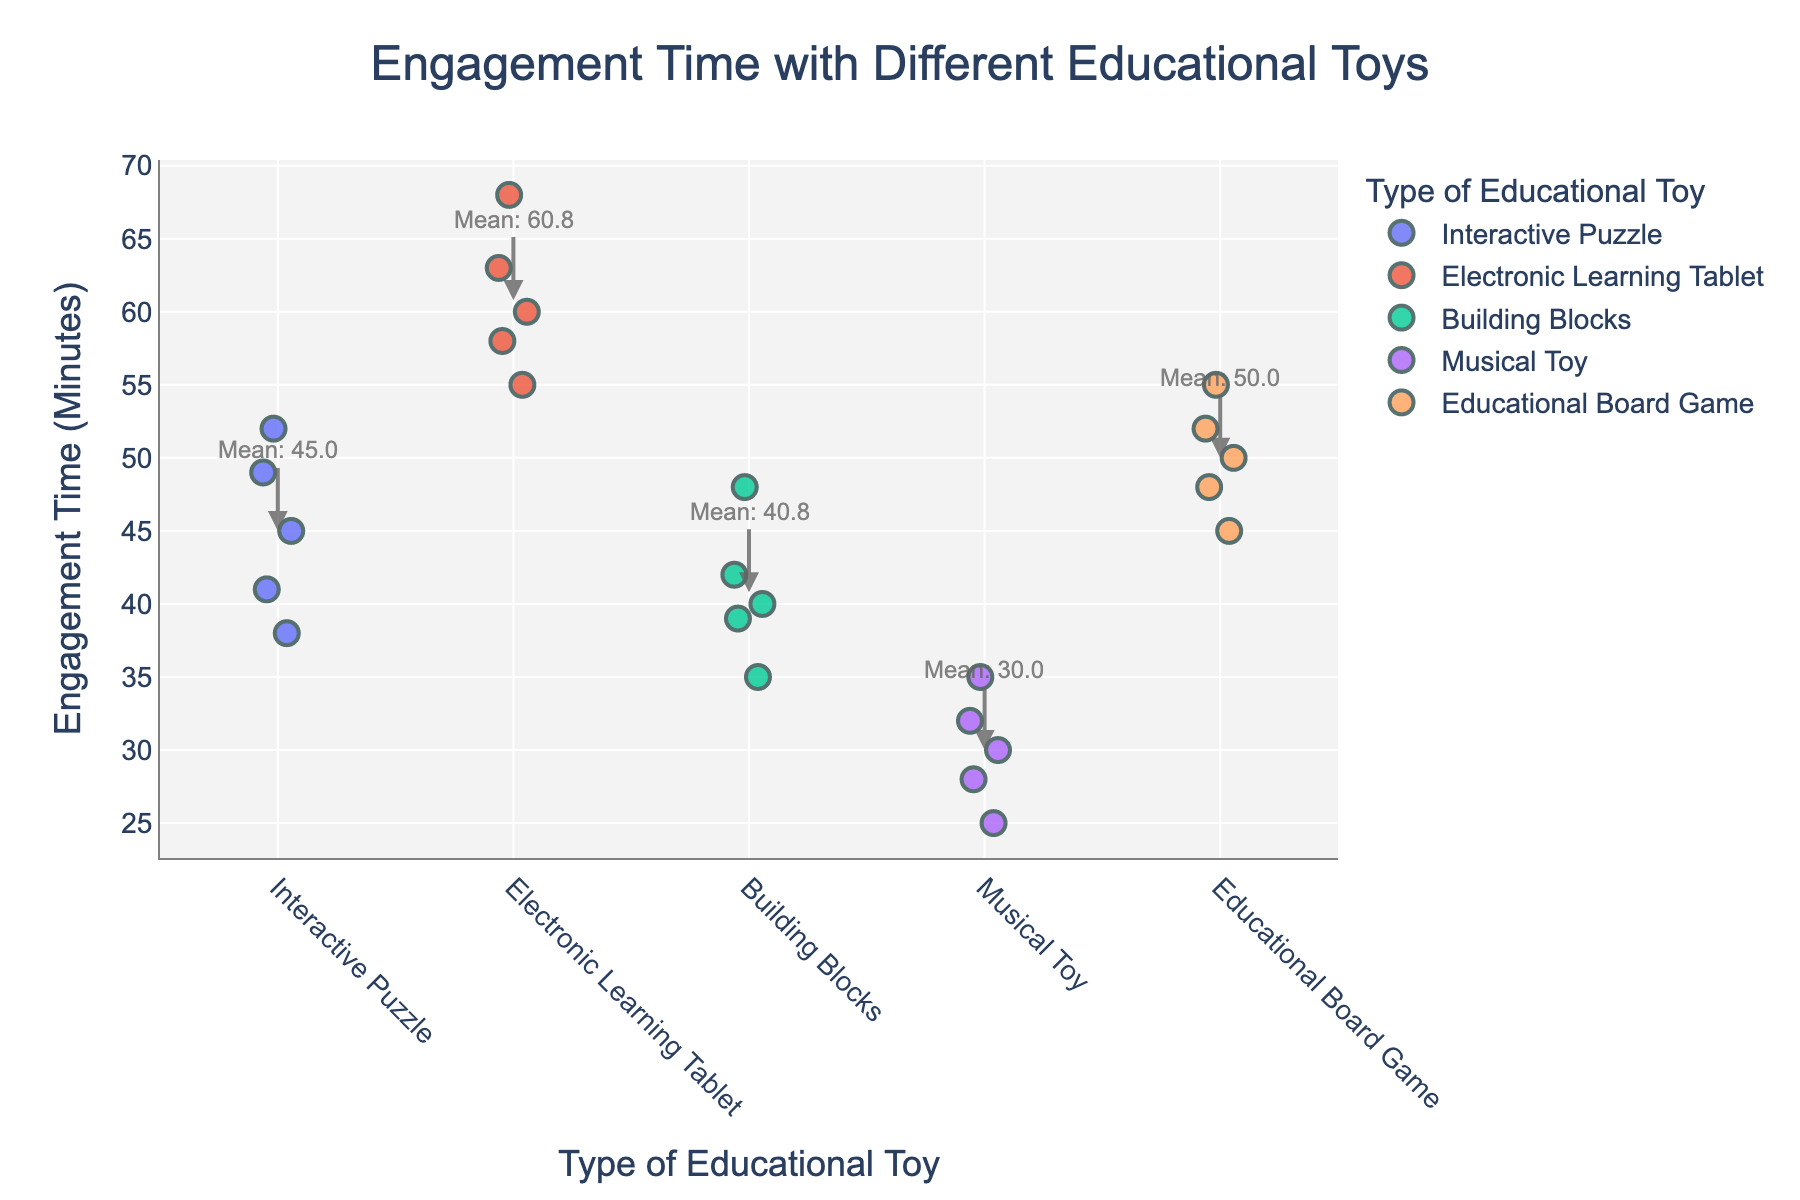What's the title of the figure? The title is usually displayed at the top of the figure. For this plot, the title is specified to be "Engagement Time with Different Educational Toys."
Answer: Engagement Time with Different Educational Toys What are the labels for the x-axis and y-axis? The x-axis and y-axis labels are usually found at the bottom and side of the plot respectively. In this plot, the x-axis is labeled as "Type of Educational Toy" and the y-axis is labeled as "Engagement Time (Minutes)."
Answer: Type of Educational Toy and Engagement Time (Minutes) How many types of educational toys are displayed in the plot? The types of educational toys can be counted from the categories on the x-axis. The unique toy types displayed on the x-axis are: "Interactive Puzzle," "Electronic Learning Tablet," "Building Blocks," "Musical Toy," and "Educational Board Game." So, there are 5 types in total.
Answer: 5 Which type of educational toy has the highest mean engagement time? The mean engagement times are annotated on the plot for each toy type. The highest mean engagement time can be identified by comparing these annotations. The electronic learning tablet has the highest mean engagement time of 60.8 minutes.
Answer: Electronic Learning Tablet What is the mean engagement time for Musical Toy? The plot lists the mean engagement time for each type of toy using annotations. The mean engagement time for Musical Toy is stated as 30.0 minutes.
Answer: 30.0 minutes Among the toys, which one has the widest range of engagement times? To determine the range, we look at the spread of the strip plot for each toy type. Electronic Learning Tablet has data points ranging from 55 to 68 minutes, which is a range of 13 minutes. This appears to be the widest range compared to other toys.
Answer: Electronic Learning Tablet What is the difference in mean engagement time between Interactive Puzzle and Building Blocks? Refer to the mean engagement time annotations for both toy types. The mean for Interactive Puzzle is 45.0, and for Building Blocks is 40.8. The difference can be calculated by subtracting 40.8 from 45.0.
Answer: 4.2 minutes Which toy type has the lowest individual engagement time recorded? The lowest individual engagement time can be identified by looking at the bottommost point in the strip plot for each toy type. The Musical Toy has an engagement time as low as 25 minutes, which is the lowest among all toy types.
Answer: Musical Toy Are there any types of toys where all recorded engagement times fall below 50 minutes? By observing the strip plot, we can see which toy types have all their individual data points below 50 minutes. Both Musical Toy (with data points at 30, 25, 35, 28, and 32) and Building Blocks (with data points at 40, 35, 48, 42, and 39) have all their engagement times below 50 minutes.
Answer: Musical Toy and Building Blocks 